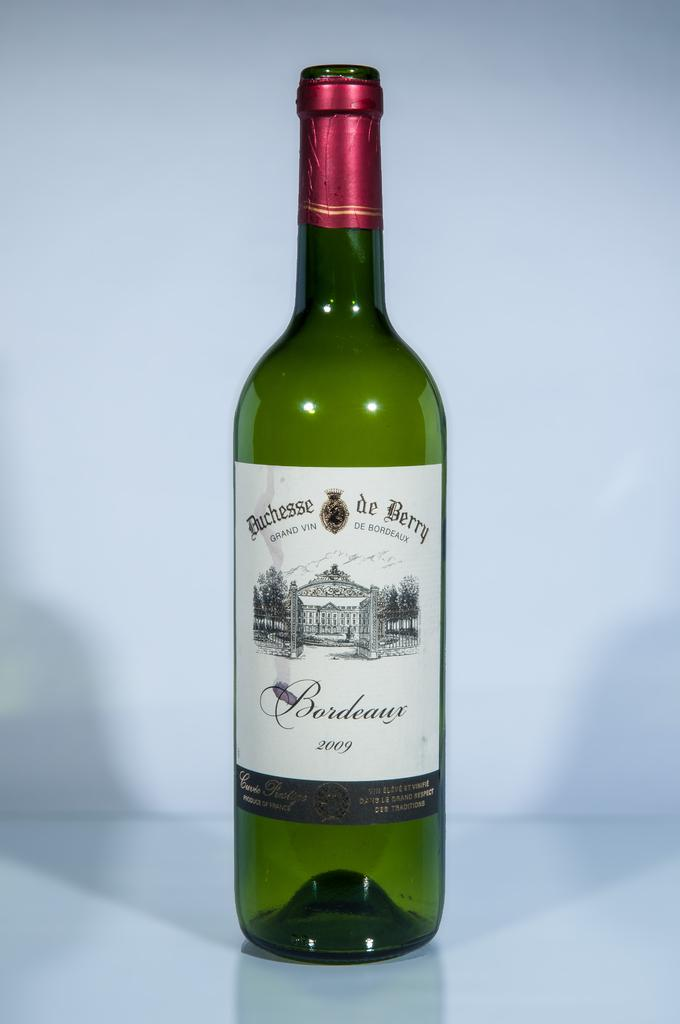<image>
Summarize the visual content of the image. Green Bordeaux wine bottle from 2009 on top of a surface. 